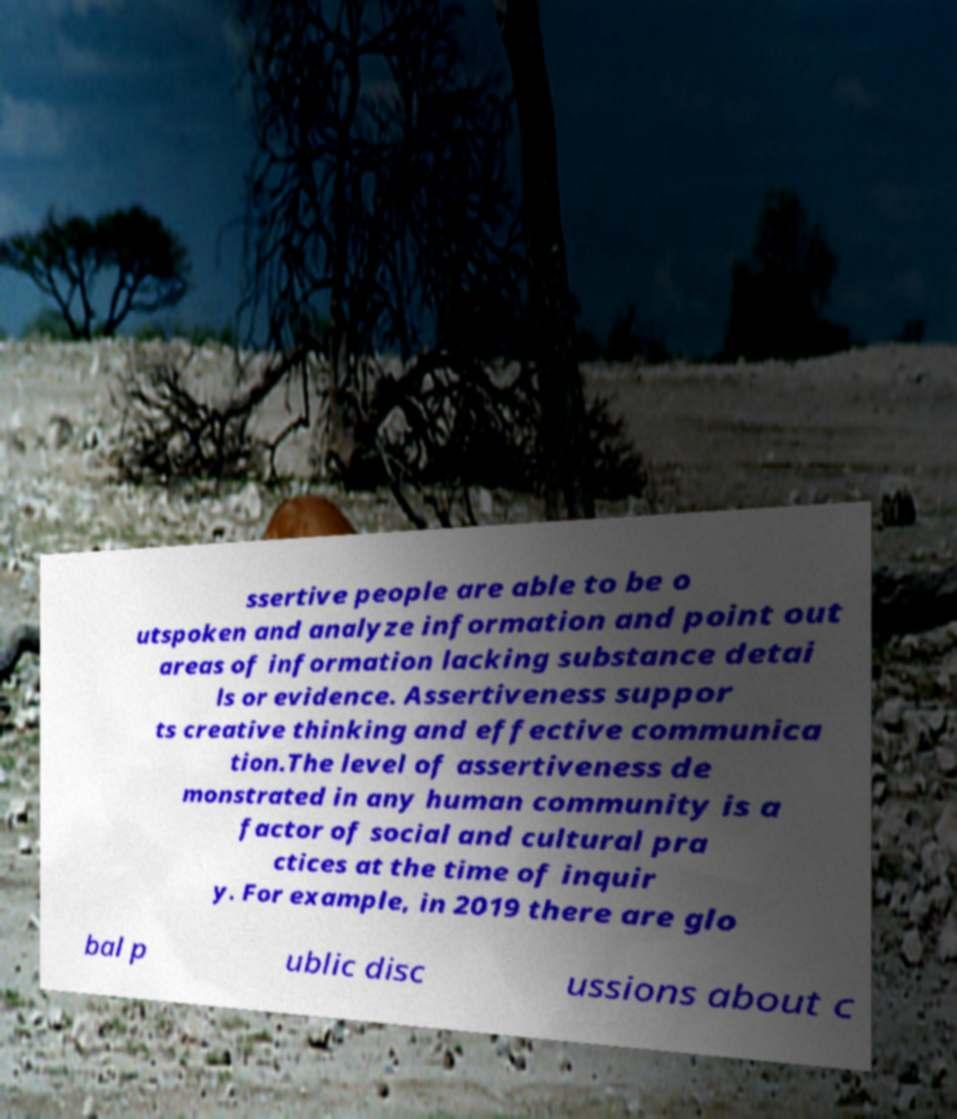I need the written content from this picture converted into text. Can you do that? ssertive people are able to be o utspoken and analyze information and point out areas of information lacking substance detai ls or evidence. Assertiveness suppor ts creative thinking and effective communica tion.The level of assertiveness de monstrated in any human community is a factor of social and cultural pra ctices at the time of inquir y. For example, in 2019 there are glo bal p ublic disc ussions about c 